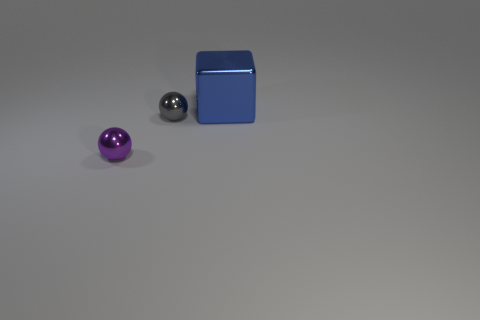The big blue metal object has what shape?
Offer a terse response. Cube. There is a thing left of the small metal sphere that is behind the small purple shiny thing; what is its color?
Your response must be concise. Purple. There is a big cube; is it the same color as the tiny sphere behind the purple metal ball?
Offer a very short reply. No. There is a object that is both on the right side of the purple metallic sphere and in front of the blue block; what is it made of?
Give a very brief answer. Metal. Are there any rubber blocks that have the same size as the purple metallic sphere?
Offer a very short reply. No. There is another ball that is the same size as the purple metallic ball; what material is it?
Keep it short and to the point. Metal. What number of tiny metal spheres are right of the gray sphere?
Give a very brief answer. 0. There is a small object in front of the tiny gray ball; is it the same shape as the blue object?
Make the answer very short. No. Are there any blue metal things that have the same shape as the small purple object?
Your answer should be very brief. No. There is a tiny thing that is to the right of the ball that is in front of the gray object; what shape is it?
Your answer should be very brief. Sphere. 